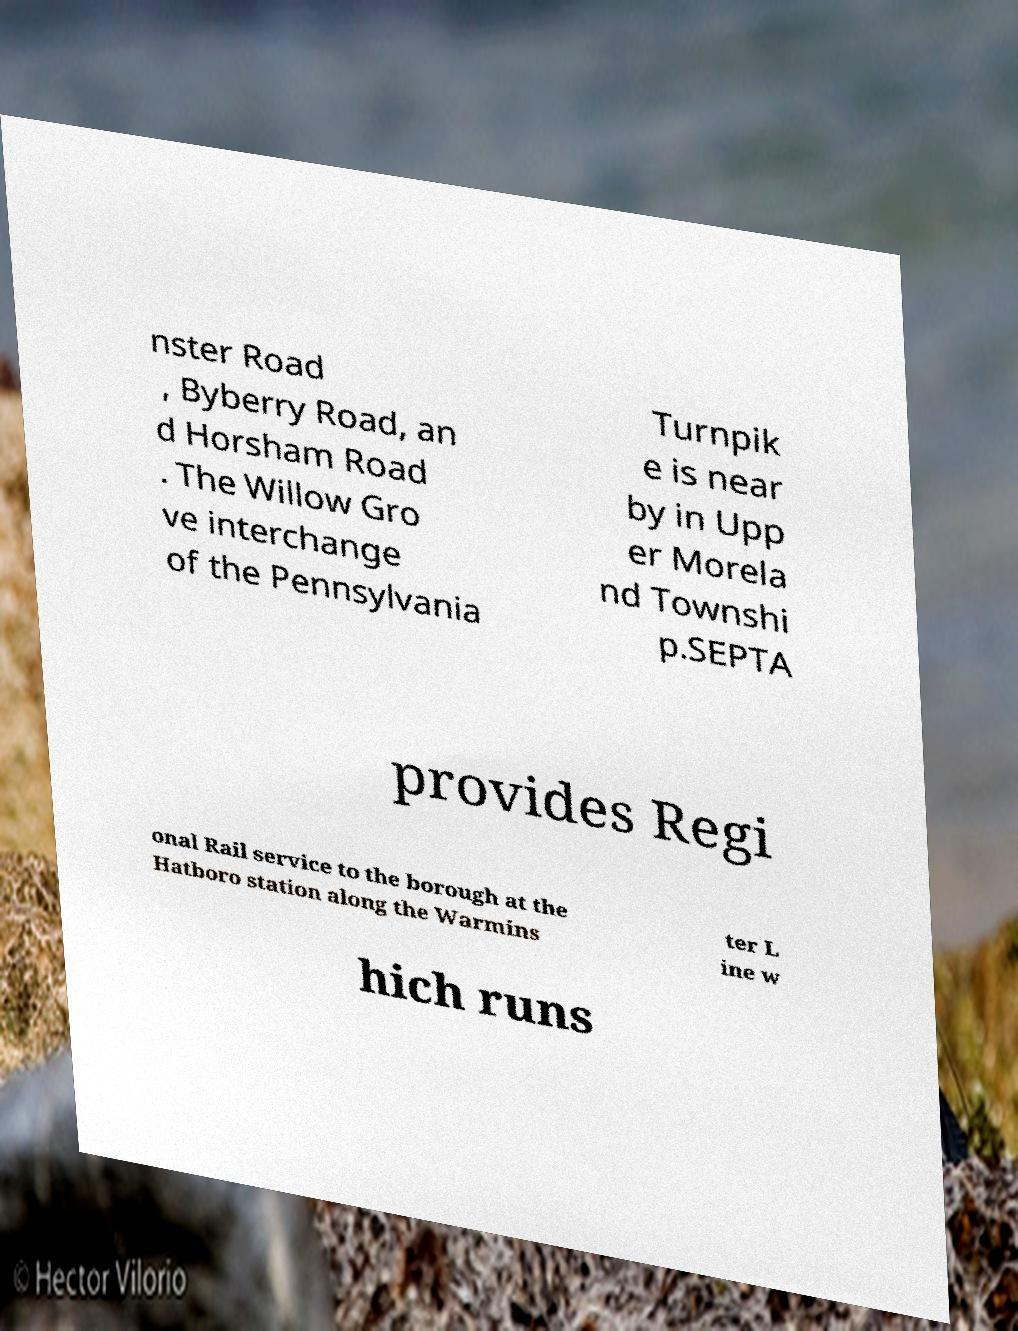There's text embedded in this image that I need extracted. Can you transcribe it verbatim? nster Road , Byberry Road, an d Horsham Road . The Willow Gro ve interchange of the Pennsylvania Turnpik e is near by in Upp er Morela nd Townshi p.SEPTA provides Regi onal Rail service to the borough at the Hatboro station along the Warmins ter L ine w hich runs 